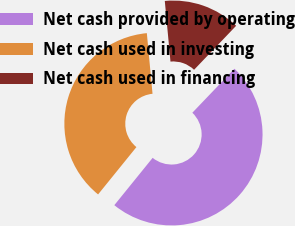<chart> <loc_0><loc_0><loc_500><loc_500><pie_chart><fcel>Net cash provided by operating<fcel>Net cash used in investing<fcel>Net cash used in financing<nl><fcel>48.69%<fcel>37.68%<fcel>13.63%<nl></chart> 